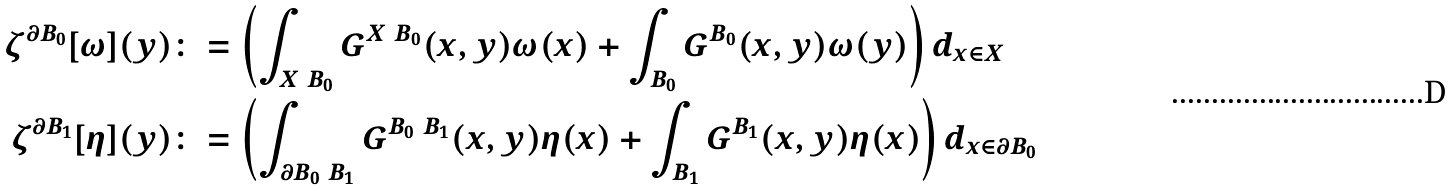Convert formula to latex. <formula><loc_0><loc_0><loc_500><loc_500>\zeta ^ { \partial B _ { 0 } } [ \omega ] ( y ) & \colon = \left ( \int _ { X \ B _ { 0 } } G ^ { X \ B _ { 0 } } ( x , y ) \omega ( x ) + \int _ { B _ { 0 } } G ^ { B _ { 0 } } ( x , y ) \omega ( y ) \right ) d _ { x \in X } \\ \zeta ^ { \partial B _ { 1 } } [ \eta ] ( y ) & \colon = \left ( \int _ { \partial B _ { 0 } \ B _ { 1 } } G ^ { B _ { 0 } \ B _ { 1 } } ( x , y ) \eta ( x ) + \int _ { B _ { 1 } } G ^ { B _ { 1 } } ( x , y ) \eta ( x ) \right ) d _ { x \in \partial B _ { 0 } } \\</formula> 